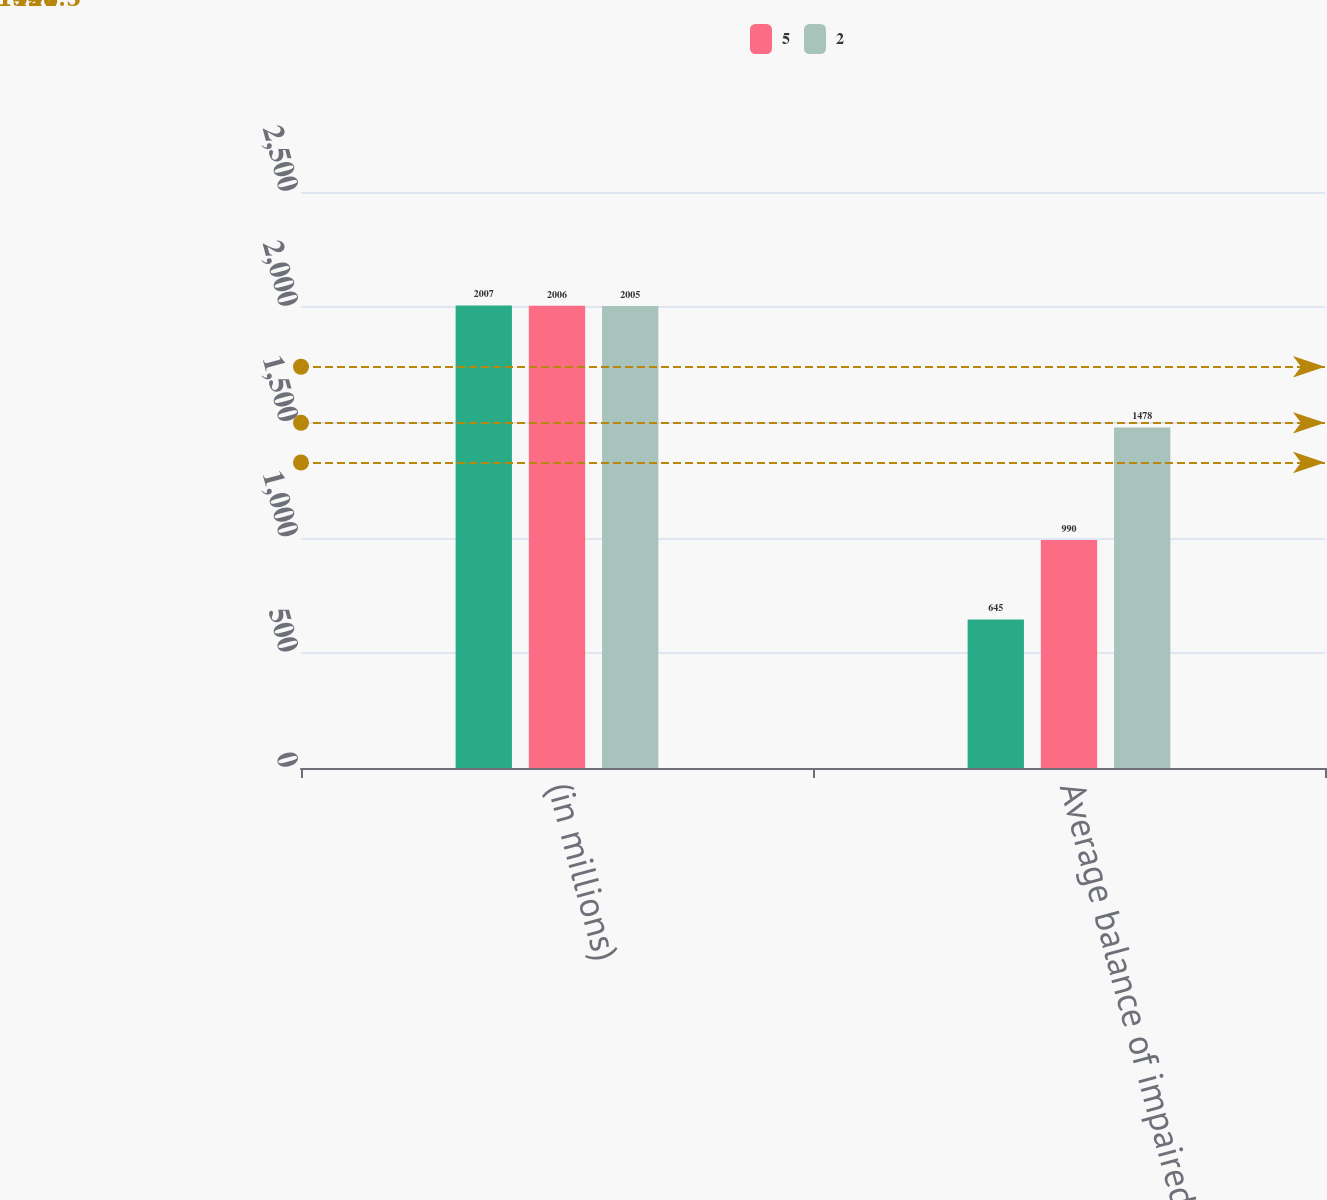<chart> <loc_0><loc_0><loc_500><loc_500><stacked_bar_chart><ecel><fcel>(in millions)<fcel>Average balance of impaired<nl><fcel>nan<fcel>2007<fcel>645<nl><fcel>5<fcel>2006<fcel>990<nl><fcel>2<fcel>2005<fcel>1478<nl></chart> 